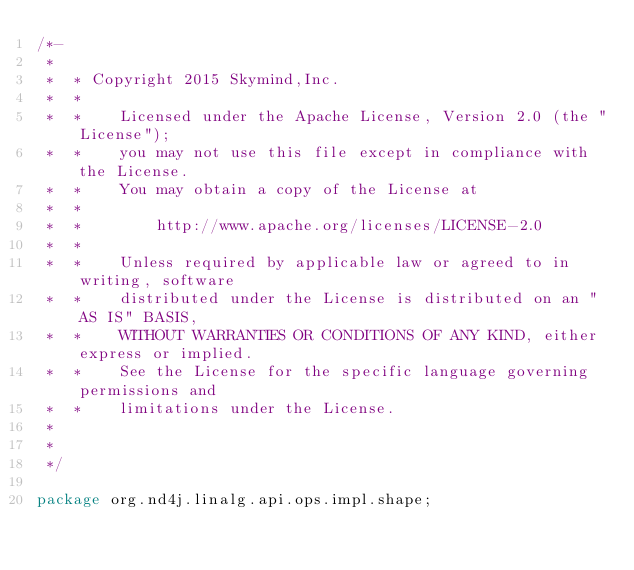Convert code to text. <code><loc_0><loc_0><loc_500><loc_500><_Java_>/*-
 *
 *  * Copyright 2015 Skymind,Inc.
 *  *
 *  *    Licensed under the Apache License, Version 2.0 (the "License");
 *  *    you may not use this file except in compliance with the License.
 *  *    You may obtain a copy of the License at
 *  *
 *  *        http://www.apache.org/licenses/LICENSE-2.0
 *  *
 *  *    Unless required by applicable law or agreed to in writing, software
 *  *    distributed under the License is distributed on an "AS IS" BASIS,
 *  *    WITHOUT WARRANTIES OR CONDITIONS OF ANY KIND, either express or implied.
 *  *    See the License for the specific language governing permissions and
 *  *    limitations under the License.
 *
 *
 */

package org.nd4j.linalg.api.ops.impl.shape;
</code> 